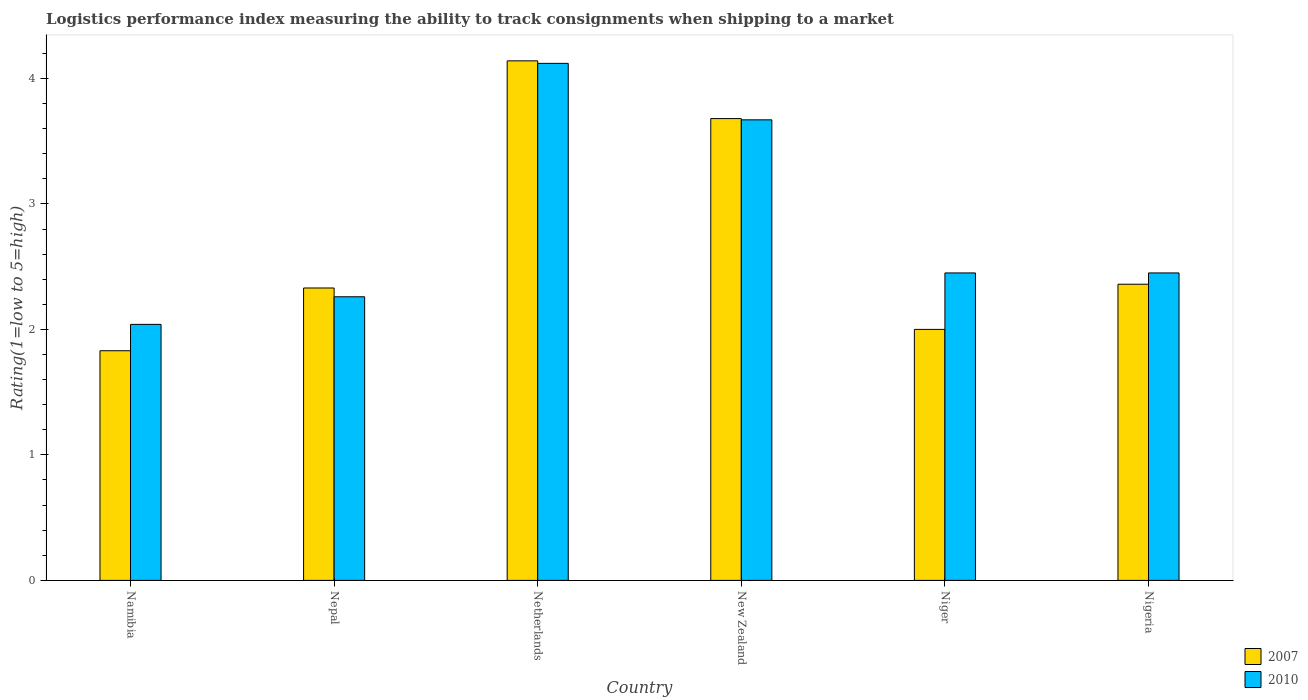How many bars are there on the 3rd tick from the left?
Provide a short and direct response. 2. What is the label of the 5th group of bars from the left?
Give a very brief answer. Niger. In how many cases, is the number of bars for a given country not equal to the number of legend labels?
Offer a terse response. 0. What is the Logistic performance index in 2010 in New Zealand?
Offer a terse response. 3.67. Across all countries, what is the maximum Logistic performance index in 2010?
Your answer should be very brief. 4.12. Across all countries, what is the minimum Logistic performance index in 2010?
Offer a terse response. 2.04. In which country was the Logistic performance index in 2010 minimum?
Provide a short and direct response. Namibia. What is the total Logistic performance index in 2007 in the graph?
Ensure brevity in your answer.  16.34. What is the difference between the Logistic performance index in 2007 in Netherlands and that in Nigeria?
Provide a short and direct response. 1.78. What is the difference between the Logistic performance index in 2010 in Niger and the Logistic performance index in 2007 in Namibia?
Ensure brevity in your answer.  0.62. What is the average Logistic performance index in 2010 per country?
Ensure brevity in your answer.  2.83. What is the difference between the Logistic performance index of/in 2007 and Logistic performance index of/in 2010 in Niger?
Your answer should be compact. -0.45. What is the ratio of the Logistic performance index in 2007 in Nepal to that in New Zealand?
Ensure brevity in your answer.  0.63. What is the difference between the highest and the second highest Logistic performance index in 2007?
Ensure brevity in your answer.  -1.32. What is the difference between the highest and the lowest Logistic performance index in 2010?
Offer a very short reply. 2.08. What does the 1st bar from the left in Namibia represents?
Your response must be concise. 2007. How many bars are there?
Make the answer very short. 12. Are all the bars in the graph horizontal?
Give a very brief answer. No. Are the values on the major ticks of Y-axis written in scientific E-notation?
Offer a terse response. No. Where does the legend appear in the graph?
Make the answer very short. Bottom right. How are the legend labels stacked?
Provide a succinct answer. Vertical. What is the title of the graph?
Offer a very short reply. Logistics performance index measuring the ability to track consignments when shipping to a market. Does "1995" appear as one of the legend labels in the graph?
Keep it short and to the point. No. What is the label or title of the X-axis?
Offer a terse response. Country. What is the label or title of the Y-axis?
Ensure brevity in your answer.  Rating(1=low to 5=high). What is the Rating(1=low to 5=high) of 2007 in Namibia?
Your response must be concise. 1.83. What is the Rating(1=low to 5=high) of 2010 in Namibia?
Provide a succinct answer. 2.04. What is the Rating(1=low to 5=high) in 2007 in Nepal?
Provide a short and direct response. 2.33. What is the Rating(1=low to 5=high) of 2010 in Nepal?
Offer a terse response. 2.26. What is the Rating(1=low to 5=high) in 2007 in Netherlands?
Offer a terse response. 4.14. What is the Rating(1=low to 5=high) in 2010 in Netherlands?
Provide a succinct answer. 4.12. What is the Rating(1=low to 5=high) in 2007 in New Zealand?
Offer a very short reply. 3.68. What is the Rating(1=low to 5=high) in 2010 in New Zealand?
Make the answer very short. 3.67. What is the Rating(1=low to 5=high) in 2007 in Niger?
Keep it short and to the point. 2. What is the Rating(1=low to 5=high) of 2010 in Niger?
Your answer should be very brief. 2.45. What is the Rating(1=low to 5=high) in 2007 in Nigeria?
Offer a terse response. 2.36. What is the Rating(1=low to 5=high) in 2010 in Nigeria?
Provide a succinct answer. 2.45. Across all countries, what is the maximum Rating(1=low to 5=high) in 2007?
Ensure brevity in your answer.  4.14. Across all countries, what is the maximum Rating(1=low to 5=high) in 2010?
Your response must be concise. 4.12. Across all countries, what is the minimum Rating(1=low to 5=high) in 2007?
Offer a terse response. 1.83. Across all countries, what is the minimum Rating(1=low to 5=high) in 2010?
Provide a succinct answer. 2.04. What is the total Rating(1=low to 5=high) of 2007 in the graph?
Your response must be concise. 16.34. What is the total Rating(1=low to 5=high) in 2010 in the graph?
Offer a terse response. 16.99. What is the difference between the Rating(1=low to 5=high) in 2010 in Namibia and that in Nepal?
Your response must be concise. -0.22. What is the difference between the Rating(1=low to 5=high) of 2007 in Namibia and that in Netherlands?
Offer a very short reply. -2.31. What is the difference between the Rating(1=low to 5=high) in 2010 in Namibia and that in Netherlands?
Give a very brief answer. -2.08. What is the difference between the Rating(1=low to 5=high) in 2007 in Namibia and that in New Zealand?
Your answer should be compact. -1.85. What is the difference between the Rating(1=low to 5=high) in 2010 in Namibia and that in New Zealand?
Your response must be concise. -1.63. What is the difference between the Rating(1=low to 5=high) in 2007 in Namibia and that in Niger?
Keep it short and to the point. -0.17. What is the difference between the Rating(1=low to 5=high) in 2010 in Namibia and that in Niger?
Your answer should be very brief. -0.41. What is the difference between the Rating(1=low to 5=high) in 2007 in Namibia and that in Nigeria?
Your answer should be very brief. -0.53. What is the difference between the Rating(1=low to 5=high) in 2010 in Namibia and that in Nigeria?
Keep it short and to the point. -0.41. What is the difference between the Rating(1=low to 5=high) of 2007 in Nepal and that in Netherlands?
Your response must be concise. -1.81. What is the difference between the Rating(1=low to 5=high) in 2010 in Nepal and that in Netherlands?
Your answer should be very brief. -1.86. What is the difference between the Rating(1=low to 5=high) in 2007 in Nepal and that in New Zealand?
Keep it short and to the point. -1.35. What is the difference between the Rating(1=low to 5=high) in 2010 in Nepal and that in New Zealand?
Ensure brevity in your answer.  -1.41. What is the difference between the Rating(1=low to 5=high) in 2007 in Nepal and that in Niger?
Make the answer very short. 0.33. What is the difference between the Rating(1=low to 5=high) in 2010 in Nepal and that in Niger?
Give a very brief answer. -0.19. What is the difference between the Rating(1=low to 5=high) of 2007 in Nepal and that in Nigeria?
Your answer should be very brief. -0.03. What is the difference between the Rating(1=low to 5=high) of 2010 in Nepal and that in Nigeria?
Make the answer very short. -0.19. What is the difference between the Rating(1=low to 5=high) in 2007 in Netherlands and that in New Zealand?
Provide a short and direct response. 0.46. What is the difference between the Rating(1=low to 5=high) in 2010 in Netherlands and that in New Zealand?
Provide a succinct answer. 0.45. What is the difference between the Rating(1=low to 5=high) of 2007 in Netherlands and that in Niger?
Give a very brief answer. 2.14. What is the difference between the Rating(1=low to 5=high) of 2010 in Netherlands and that in Niger?
Your response must be concise. 1.67. What is the difference between the Rating(1=low to 5=high) in 2007 in Netherlands and that in Nigeria?
Offer a terse response. 1.78. What is the difference between the Rating(1=low to 5=high) of 2010 in Netherlands and that in Nigeria?
Make the answer very short. 1.67. What is the difference between the Rating(1=low to 5=high) of 2007 in New Zealand and that in Niger?
Keep it short and to the point. 1.68. What is the difference between the Rating(1=low to 5=high) in 2010 in New Zealand and that in Niger?
Keep it short and to the point. 1.22. What is the difference between the Rating(1=low to 5=high) in 2007 in New Zealand and that in Nigeria?
Ensure brevity in your answer.  1.32. What is the difference between the Rating(1=low to 5=high) of 2010 in New Zealand and that in Nigeria?
Offer a very short reply. 1.22. What is the difference between the Rating(1=low to 5=high) in 2007 in Niger and that in Nigeria?
Provide a succinct answer. -0.36. What is the difference between the Rating(1=low to 5=high) in 2007 in Namibia and the Rating(1=low to 5=high) in 2010 in Nepal?
Your answer should be compact. -0.43. What is the difference between the Rating(1=low to 5=high) in 2007 in Namibia and the Rating(1=low to 5=high) in 2010 in Netherlands?
Offer a terse response. -2.29. What is the difference between the Rating(1=low to 5=high) of 2007 in Namibia and the Rating(1=low to 5=high) of 2010 in New Zealand?
Give a very brief answer. -1.84. What is the difference between the Rating(1=low to 5=high) of 2007 in Namibia and the Rating(1=low to 5=high) of 2010 in Niger?
Offer a very short reply. -0.62. What is the difference between the Rating(1=low to 5=high) of 2007 in Namibia and the Rating(1=low to 5=high) of 2010 in Nigeria?
Provide a succinct answer. -0.62. What is the difference between the Rating(1=low to 5=high) of 2007 in Nepal and the Rating(1=low to 5=high) of 2010 in Netherlands?
Make the answer very short. -1.79. What is the difference between the Rating(1=low to 5=high) of 2007 in Nepal and the Rating(1=low to 5=high) of 2010 in New Zealand?
Ensure brevity in your answer.  -1.34. What is the difference between the Rating(1=low to 5=high) in 2007 in Nepal and the Rating(1=low to 5=high) in 2010 in Niger?
Your answer should be very brief. -0.12. What is the difference between the Rating(1=low to 5=high) of 2007 in Nepal and the Rating(1=low to 5=high) of 2010 in Nigeria?
Offer a very short reply. -0.12. What is the difference between the Rating(1=low to 5=high) in 2007 in Netherlands and the Rating(1=low to 5=high) in 2010 in New Zealand?
Ensure brevity in your answer.  0.47. What is the difference between the Rating(1=low to 5=high) of 2007 in Netherlands and the Rating(1=low to 5=high) of 2010 in Niger?
Keep it short and to the point. 1.69. What is the difference between the Rating(1=low to 5=high) in 2007 in Netherlands and the Rating(1=low to 5=high) in 2010 in Nigeria?
Keep it short and to the point. 1.69. What is the difference between the Rating(1=low to 5=high) of 2007 in New Zealand and the Rating(1=low to 5=high) of 2010 in Niger?
Offer a very short reply. 1.23. What is the difference between the Rating(1=low to 5=high) of 2007 in New Zealand and the Rating(1=low to 5=high) of 2010 in Nigeria?
Your answer should be very brief. 1.23. What is the difference between the Rating(1=low to 5=high) in 2007 in Niger and the Rating(1=low to 5=high) in 2010 in Nigeria?
Offer a terse response. -0.45. What is the average Rating(1=low to 5=high) in 2007 per country?
Give a very brief answer. 2.72. What is the average Rating(1=low to 5=high) in 2010 per country?
Provide a succinct answer. 2.83. What is the difference between the Rating(1=low to 5=high) in 2007 and Rating(1=low to 5=high) in 2010 in Namibia?
Your response must be concise. -0.21. What is the difference between the Rating(1=low to 5=high) of 2007 and Rating(1=low to 5=high) of 2010 in Nepal?
Provide a short and direct response. 0.07. What is the difference between the Rating(1=low to 5=high) of 2007 and Rating(1=low to 5=high) of 2010 in New Zealand?
Offer a very short reply. 0.01. What is the difference between the Rating(1=low to 5=high) in 2007 and Rating(1=low to 5=high) in 2010 in Niger?
Offer a very short reply. -0.45. What is the difference between the Rating(1=low to 5=high) of 2007 and Rating(1=low to 5=high) of 2010 in Nigeria?
Give a very brief answer. -0.09. What is the ratio of the Rating(1=low to 5=high) in 2007 in Namibia to that in Nepal?
Offer a terse response. 0.79. What is the ratio of the Rating(1=low to 5=high) in 2010 in Namibia to that in Nepal?
Your answer should be compact. 0.9. What is the ratio of the Rating(1=low to 5=high) of 2007 in Namibia to that in Netherlands?
Provide a succinct answer. 0.44. What is the ratio of the Rating(1=low to 5=high) of 2010 in Namibia to that in Netherlands?
Make the answer very short. 0.5. What is the ratio of the Rating(1=low to 5=high) of 2007 in Namibia to that in New Zealand?
Your answer should be compact. 0.5. What is the ratio of the Rating(1=low to 5=high) in 2010 in Namibia to that in New Zealand?
Your answer should be compact. 0.56. What is the ratio of the Rating(1=low to 5=high) in 2007 in Namibia to that in Niger?
Ensure brevity in your answer.  0.92. What is the ratio of the Rating(1=low to 5=high) of 2010 in Namibia to that in Niger?
Keep it short and to the point. 0.83. What is the ratio of the Rating(1=low to 5=high) in 2007 in Namibia to that in Nigeria?
Give a very brief answer. 0.78. What is the ratio of the Rating(1=low to 5=high) of 2010 in Namibia to that in Nigeria?
Provide a short and direct response. 0.83. What is the ratio of the Rating(1=low to 5=high) in 2007 in Nepal to that in Netherlands?
Offer a terse response. 0.56. What is the ratio of the Rating(1=low to 5=high) of 2010 in Nepal to that in Netherlands?
Offer a terse response. 0.55. What is the ratio of the Rating(1=low to 5=high) of 2007 in Nepal to that in New Zealand?
Offer a terse response. 0.63. What is the ratio of the Rating(1=low to 5=high) of 2010 in Nepal to that in New Zealand?
Provide a succinct answer. 0.62. What is the ratio of the Rating(1=low to 5=high) in 2007 in Nepal to that in Niger?
Make the answer very short. 1.17. What is the ratio of the Rating(1=low to 5=high) in 2010 in Nepal to that in Niger?
Make the answer very short. 0.92. What is the ratio of the Rating(1=low to 5=high) of 2007 in Nepal to that in Nigeria?
Ensure brevity in your answer.  0.99. What is the ratio of the Rating(1=low to 5=high) of 2010 in Nepal to that in Nigeria?
Your answer should be compact. 0.92. What is the ratio of the Rating(1=low to 5=high) of 2010 in Netherlands to that in New Zealand?
Offer a terse response. 1.12. What is the ratio of the Rating(1=low to 5=high) of 2007 in Netherlands to that in Niger?
Your response must be concise. 2.07. What is the ratio of the Rating(1=low to 5=high) of 2010 in Netherlands to that in Niger?
Ensure brevity in your answer.  1.68. What is the ratio of the Rating(1=low to 5=high) in 2007 in Netherlands to that in Nigeria?
Your answer should be compact. 1.75. What is the ratio of the Rating(1=low to 5=high) of 2010 in Netherlands to that in Nigeria?
Your response must be concise. 1.68. What is the ratio of the Rating(1=low to 5=high) of 2007 in New Zealand to that in Niger?
Provide a short and direct response. 1.84. What is the ratio of the Rating(1=low to 5=high) in 2010 in New Zealand to that in Niger?
Offer a very short reply. 1.5. What is the ratio of the Rating(1=low to 5=high) of 2007 in New Zealand to that in Nigeria?
Provide a short and direct response. 1.56. What is the ratio of the Rating(1=low to 5=high) in 2010 in New Zealand to that in Nigeria?
Make the answer very short. 1.5. What is the ratio of the Rating(1=low to 5=high) in 2007 in Niger to that in Nigeria?
Ensure brevity in your answer.  0.85. What is the ratio of the Rating(1=low to 5=high) in 2010 in Niger to that in Nigeria?
Your answer should be very brief. 1. What is the difference between the highest and the second highest Rating(1=low to 5=high) in 2007?
Offer a very short reply. 0.46. What is the difference between the highest and the second highest Rating(1=low to 5=high) of 2010?
Your response must be concise. 0.45. What is the difference between the highest and the lowest Rating(1=low to 5=high) in 2007?
Your response must be concise. 2.31. What is the difference between the highest and the lowest Rating(1=low to 5=high) in 2010?
Give a very brief answer. 2.08. 